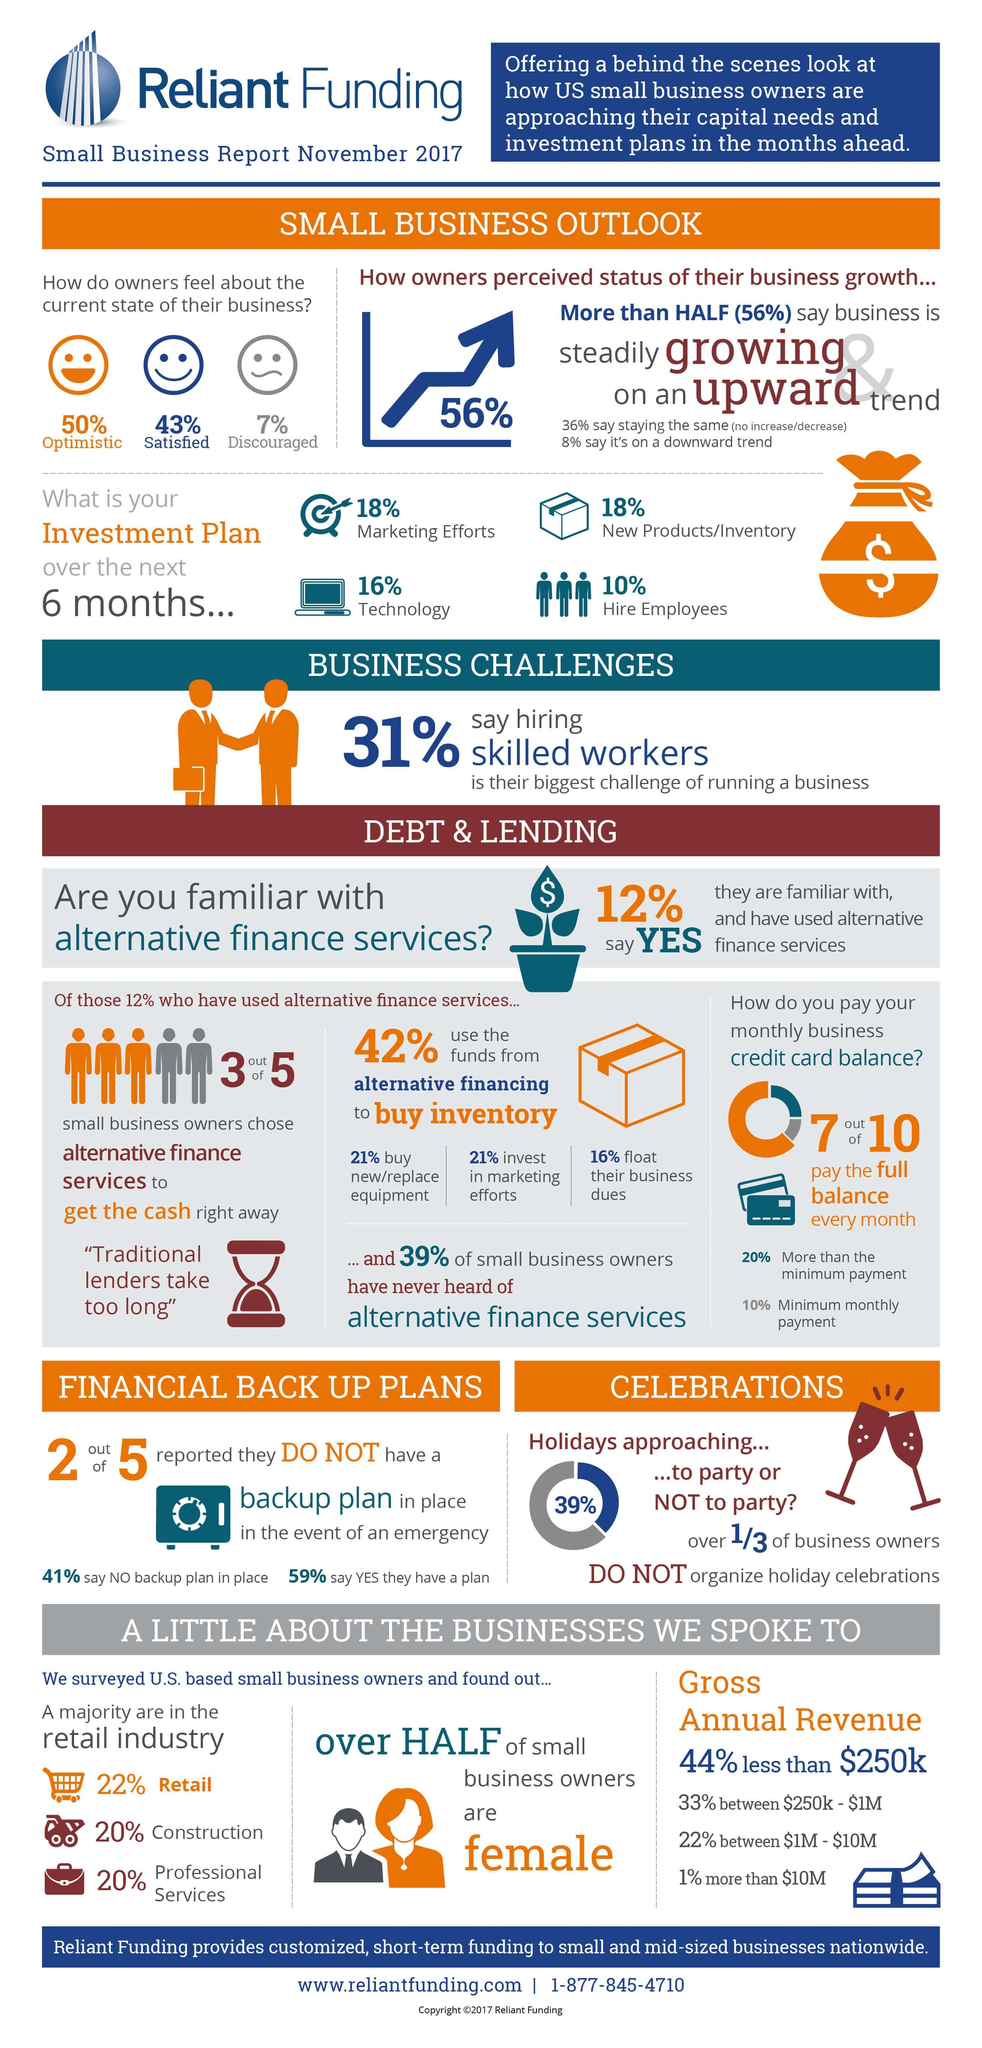Out of 10, how many didn't pay the full balance every month?
Answer the question with a short phrase. 3 What percentage of owners are encouraged? 93% What percentage of owners are in retail and construction, taken together? 42% What percentage of owners are in professional services and construction, taken together? 40% What percentage of owners are pessimistic? 50% What percentage of owners are unsatisfied? 57% 